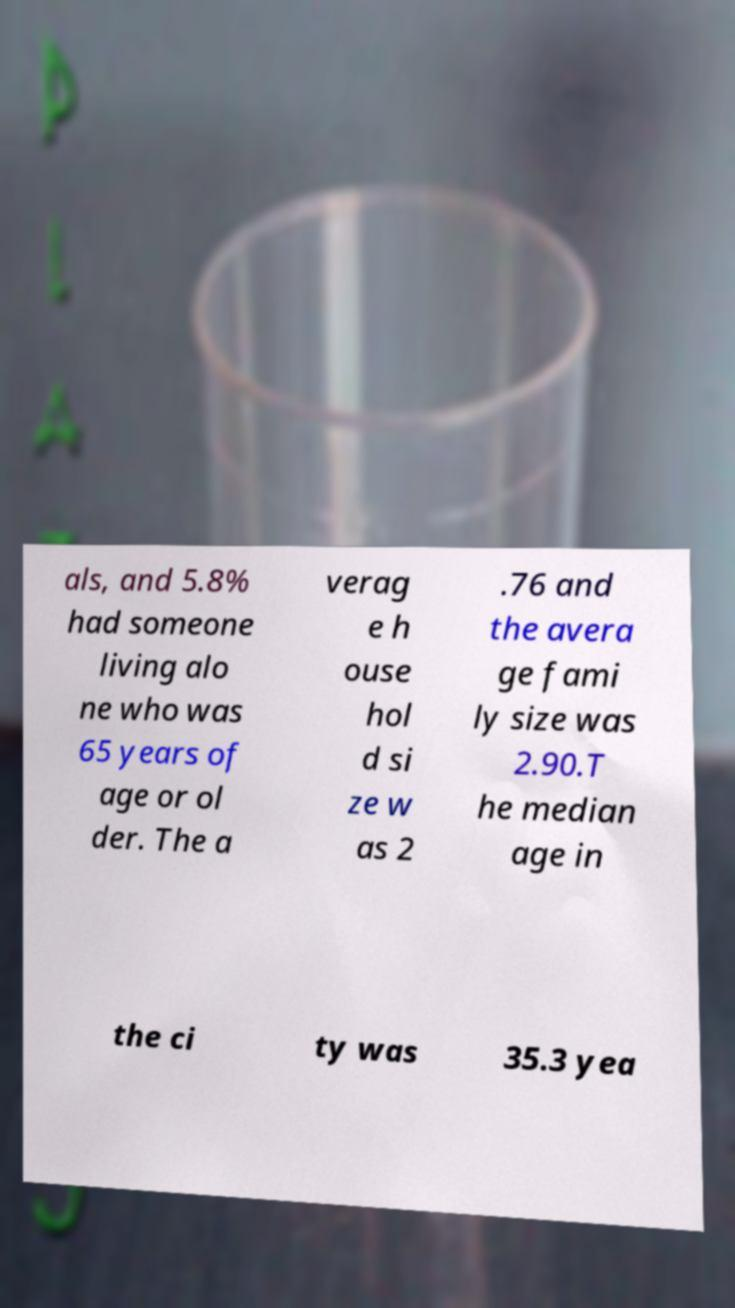There's text embedded in this image that I need extracted. Can you transcribe it verbatim? als, and 5.8% had someone living alo ne who was 65 years of age or ol der. The a verag e h ouse hol d si ze w as 2 .76 and the avera ge fami ly size was 2.90.T he median age in the ci ty was 35.3 yea 